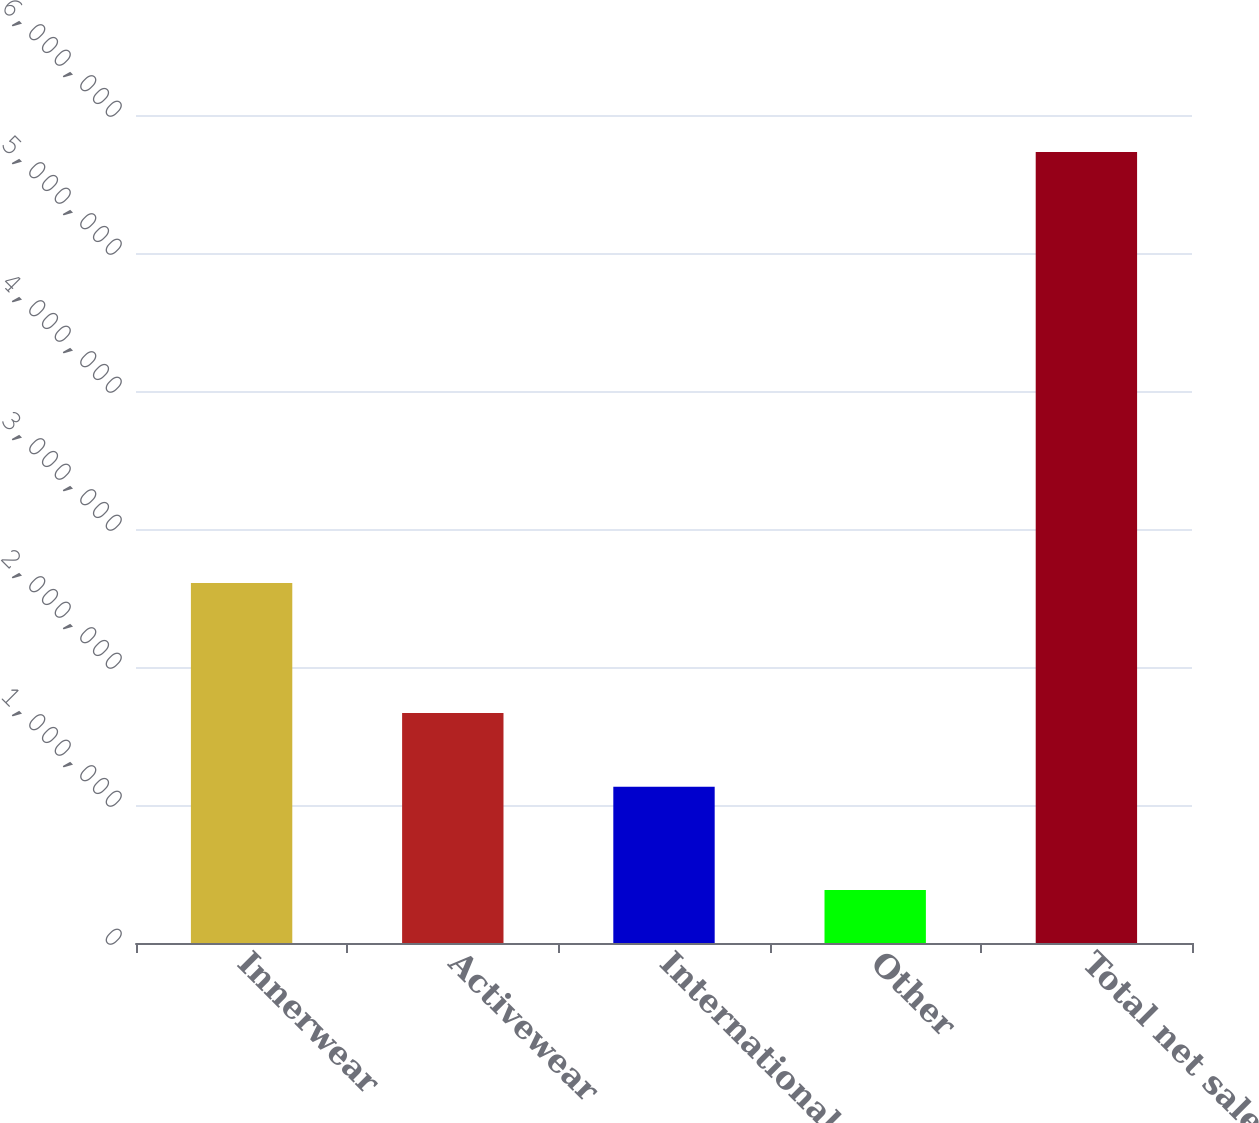<chart> <loc_0><loc_0><loc_500><loc_500><bar_chart><fcel>Innerwear<fcel>Activewear<fcel>International<fcel>Other<fcel>Total net sales<nl><fcel>2.6094e+06<fcel>1.66738e+06<fcel>1.13264e+06<fcel>384087<fcel>5.73155e+06<nl></chart> 